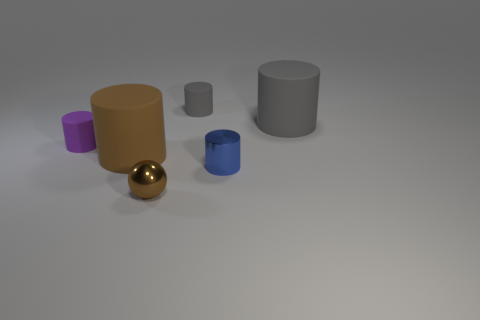Subtract all purple cylinders. How many cylinders are left? 4 Subtract all brown cylinders. How many cylinders are left? 4 Add 3 small balls. How many objects exist? 9 Subtract all brown cylinders. Subtract all blue spheres. How many cylinders are left? 4 Subtract all cylinders. How many objects are left? 1 Subtract 0 blue cubes. How many objects are left? 6 Subtract all purple cubes. Subtract all brown metal things. How many objects are left? 5 Add 5 brown rubber cylinders. How many brown rubber cylinders are left? 6 Add 2 big yellow balls. How many big yellow balls exist? 2 